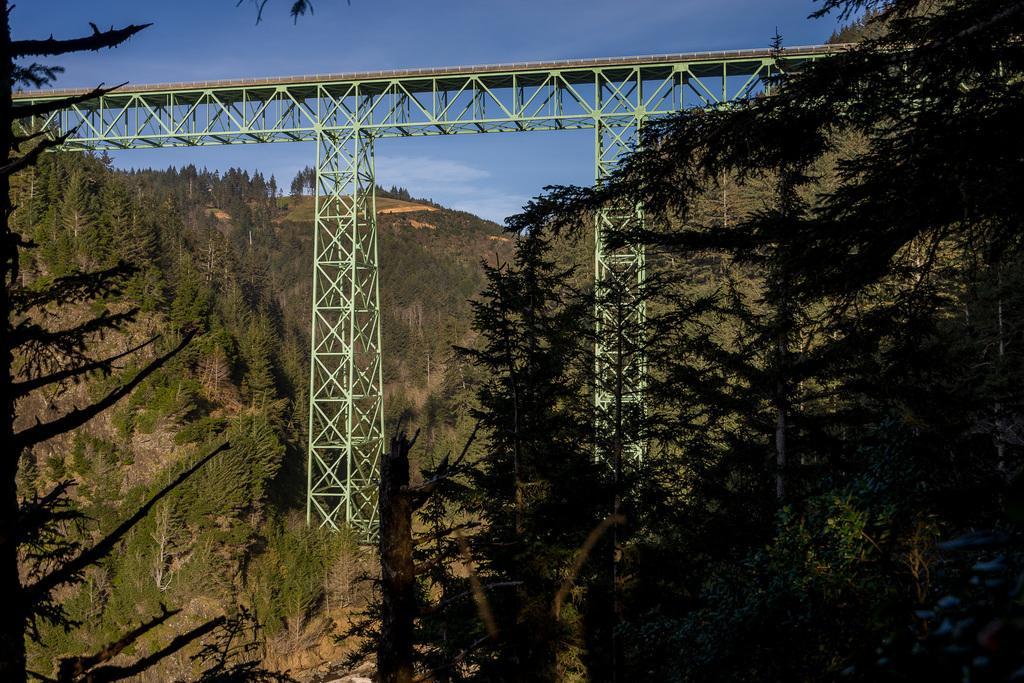Describe this image in one or two sentences. In the image there are hills with trees. In between them there is a bridge with towers and fencing of rods. 